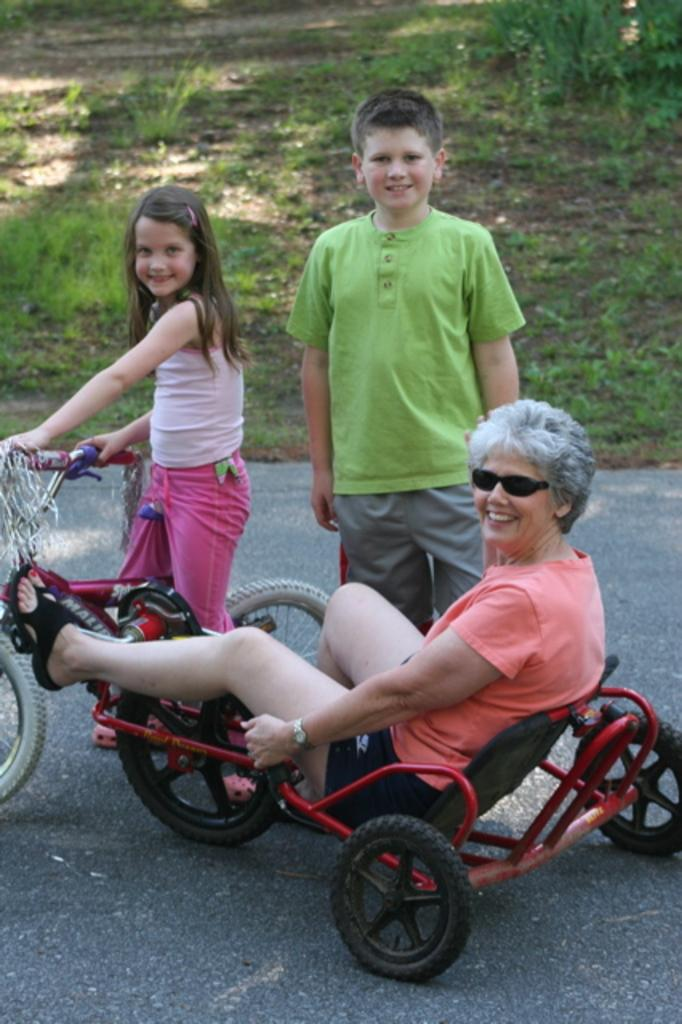What is the person in the wheelchair doing in the image? The person in the wheelchair is sitting and smiling. What is the girl on the bicycle doing in the image? The girl on the bicycle is sitting and smiling. Can you describe the boy on the right side of the image? There is a boy on the right side of the image, but no specific details about his actions or expressions are provided. What type of cap is the beginner wearing in the image? There is no beginner or cap present in the image. 